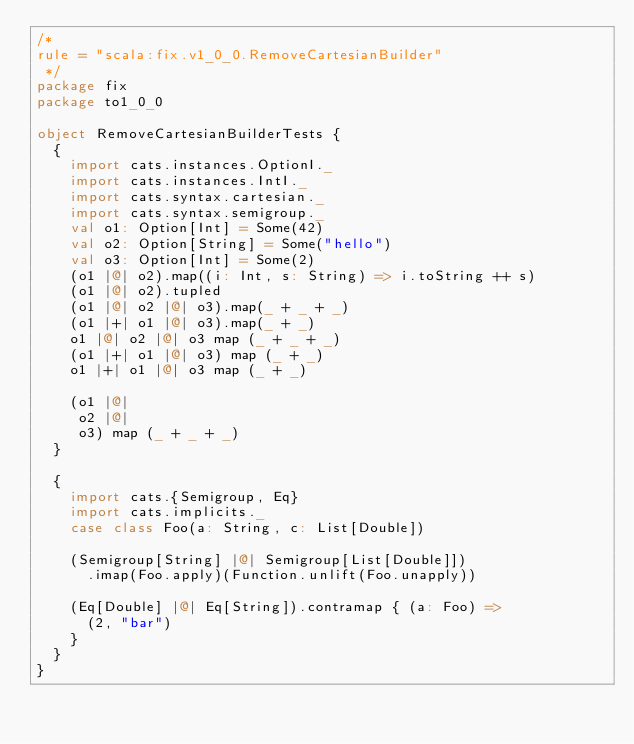<code> <loc_0><loc_0><loc_500><loc_500><_Scala_>/*
rule = "scala:fix.v1_0_0.RemoveCartesianBuilder"
 */
package fix
package to1_0_0

object RemoveCartesianBuilderTests {
  {
    import cats.instances.OptionI._
    import cats.instances.IntI._
    import cats.syntax.cartesian._
    import cats.syntax.semigroup._
    val o1: Option[Int] = Some(42)
    val o2: Option[String] = Some("hello")
    val o3: Option[Int] = Some(2)
    (o1 |@| o2).map((i: Int, s: String) => i.toString ++ s)
    (o1 |@| o2).tupled
    (o1 |@| o2 |@| o3).map(_ + _ + _)
    (o1 |+| o1 |@| o3).map(_ + _)
    o1 |@| o2 |@| o3 map (_ + _ + _)
    (o1 |+| o1 |@| o3) map (_ + _)
    o1 |+| o1 |@| o3 map (_ + _)

    (o1 |@|
     o2 |@|
     o3) map (_ + _ + _)
  }

  {
    import cats.{Semigroup, Eq}
    import cats.implicits._
    case class Foo(a: String, c: List[Double])

    (Semigroup[String] |@| Semigroup[List[Double]])
      .imap(Foo.apply)(Function.unlift(Foo.unapply))

    (Eq[Double] |@| Eq[String]).contramap { (a: Foo) =>
      (2, "bar")
    }
  }
}
</code> 